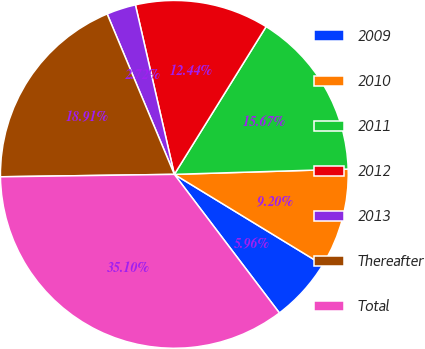Convert chart. <chart><loc_0><loc_0><loc_500><loc_500><pie_chart><fcel>2009<fcel>2010<fcel>2011<fcel>2012<fcel>2013<fcel>Thereafter<fcel>Total<nl><fcel>5.96%<fcel>9.2%<fcel>15.67%<fcel>12.44%<fcel>2.72%<fcel>18.91%<fcel>35.1%<nl></chart> 